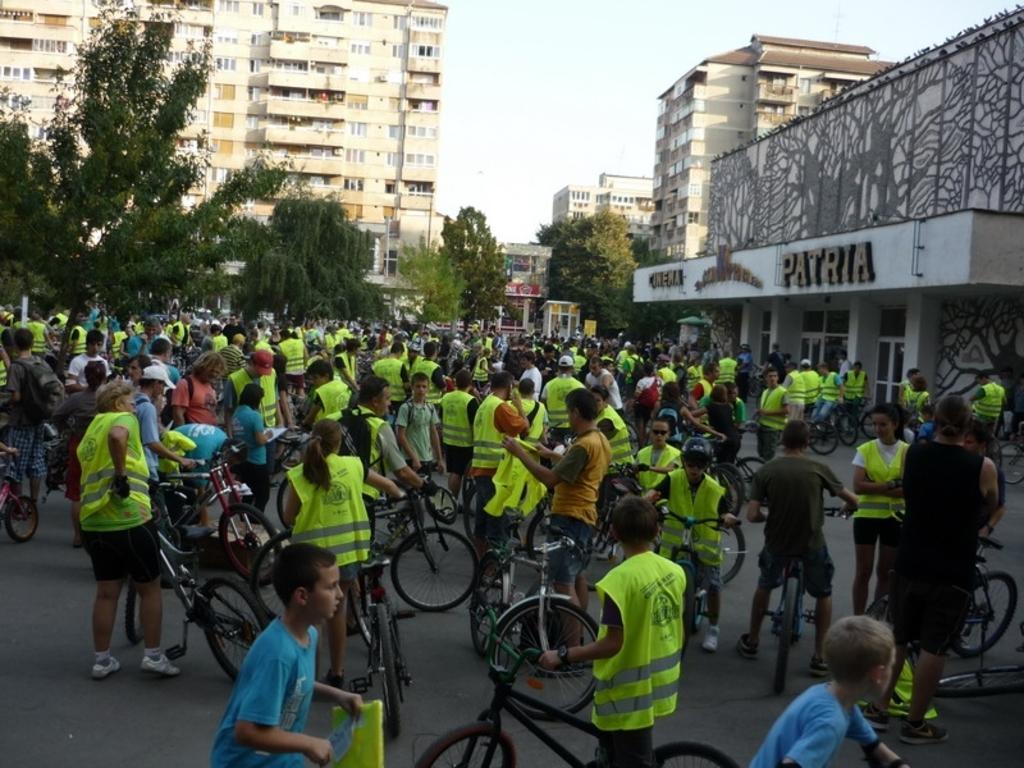Please provide a concise description of this image. In this image we can see a group of people standing on the road holding the bicycles. On the backside we can see a group of buildings, a signboard with some text on it, a group of trees and the sky which looks cloudy. 